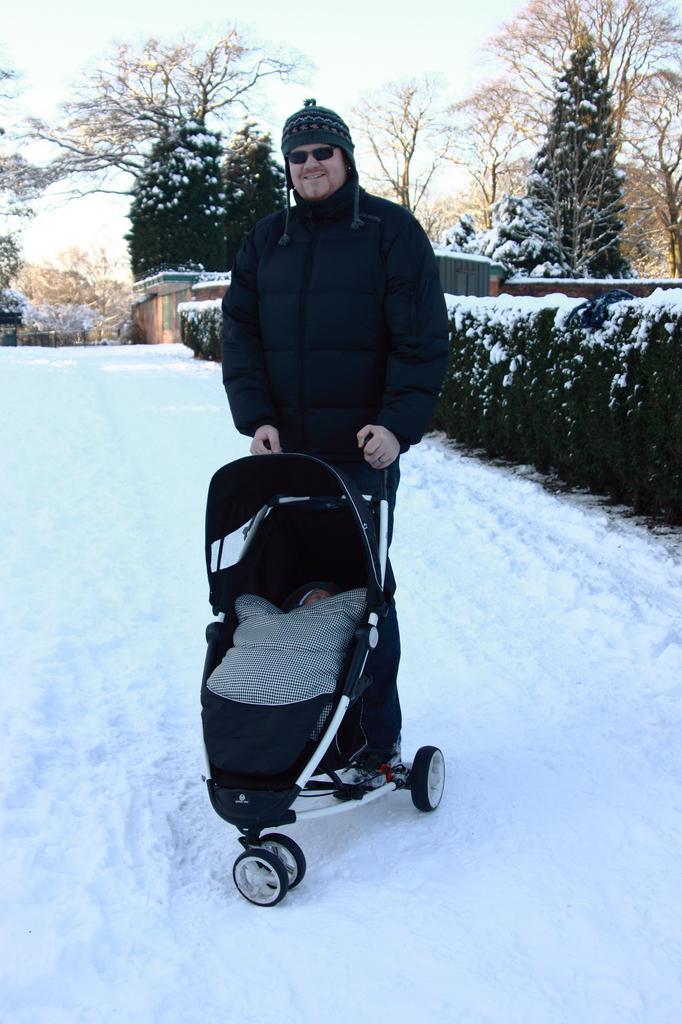How would you summarize this image in a sentence or two? In this picture I can see a man in the middle, he is holding the baby cart. There is the snow, on the right side I can see trees, at the top there is the sky. 